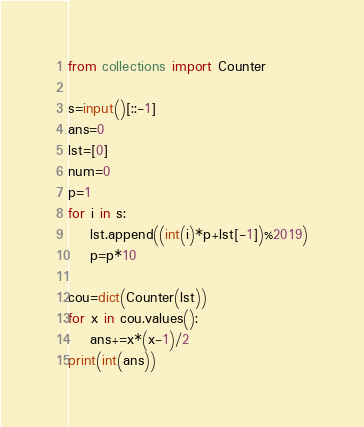<code> <loc_0><loc_0><loc_500><loc_500><_Python_>from collections import Counter

s=input()[::-1]
ans=0
lst=[0]
num=0
p=1
for i in s:
    lst.append((int(i)*p+lst[-1])%2019)
    p=p*10

cou=dict(Counter(lst))
for x in cou.values():
    ans+=x*(x-1)/2
print(int(ans))</code> 